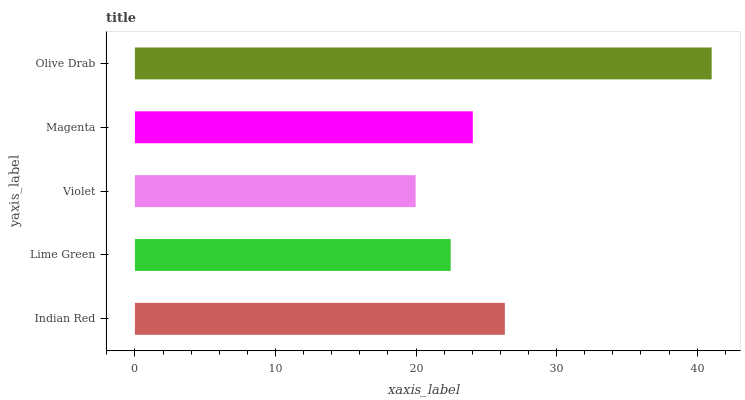Is Violet the minimum?
Answer yes or no. Yes. Is Olive Drab the maximum?
Answer yes or no. Yes. Is Lime Green the minimum?
Answer yes or no. No. Is Lime Green the maximum?
Answer yes or no. No. Is Indian Red greater than Lime Green?
Answer yes or no. Yes. Is Lime Green less than Indian Red?
Answer yes or no. Yes. Is Lime Green greater than Indian Red?
Answer yes or no. No. Is Indian Red less than Lime Green?
Answer yes or no. No. Is Magenta the high median?
Answer yes or no. Yes. Is Magenta the low median?
Answer yes or no. Yes. Is Lime Green the high median?
Answer yes or no. No. Is Lime Green the low median?
Answer yes or no. No. 